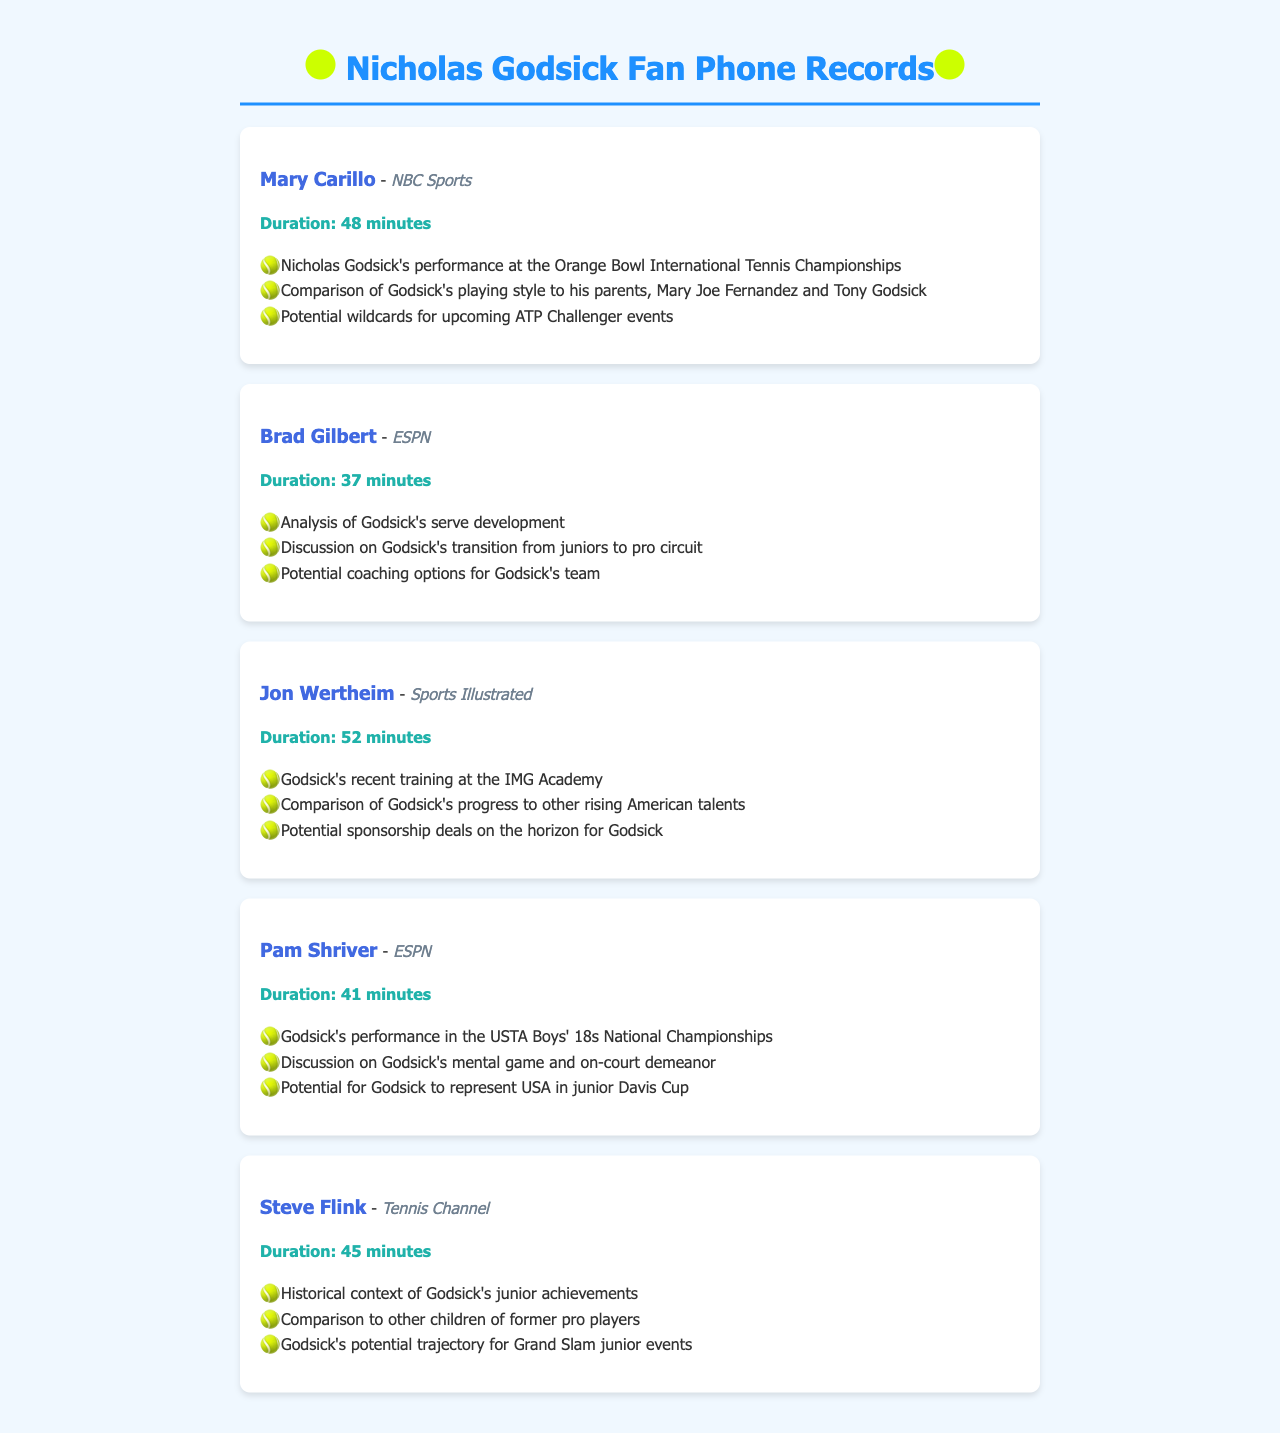What is the duration of the call with Mary Carillo? The duration of the call with Mary Carillo is explicitly stated in the document.
Answer: 48 minutes Who did Brad Gilbert discuss during his call? The document mentions that Brad Gilbert's call was about Nicholas Godsick and his serve development.
Answer: Nicholas Godsick What organization is Jon Wertheim associated with? The document shows that Jon Wertheim is associated with Sports Illustrated.
Answer: Sports Illustrated What was a topic discussed by Pam Shriver in her call? The document lists multiple topics discussed in Pam Shriver's call, including Godsick's performance in a specific national championship.
Answer: Godsick's performance in the USTA Boys' 18s National Championships Who discussed Godsick's potential trajectory for Grand Slam junior events? The document clearly states that Steve Flink provided insights on Godsick's potential trajectory.
Answer: Steve Flink How long was the call with Jon Wertheim? The document indicates the length of the call with Jon Wertheim.
Answer: 52 minutes What is a common theme discussed across the calls? The document highlights various aspects of Nicholas Godsick's career, showing a focus on his performance and potential in tennis.
Answer: Nicholas Godsick's performance and potential How many calls discussed Godsick's training? The document mentions that at least one call covered Godsick's training context.
Answer: One What profession is Steve Flink associated with? The document specifies that Steve Flink is associated with Tennis Channel.
Answer: Tennis Channel 